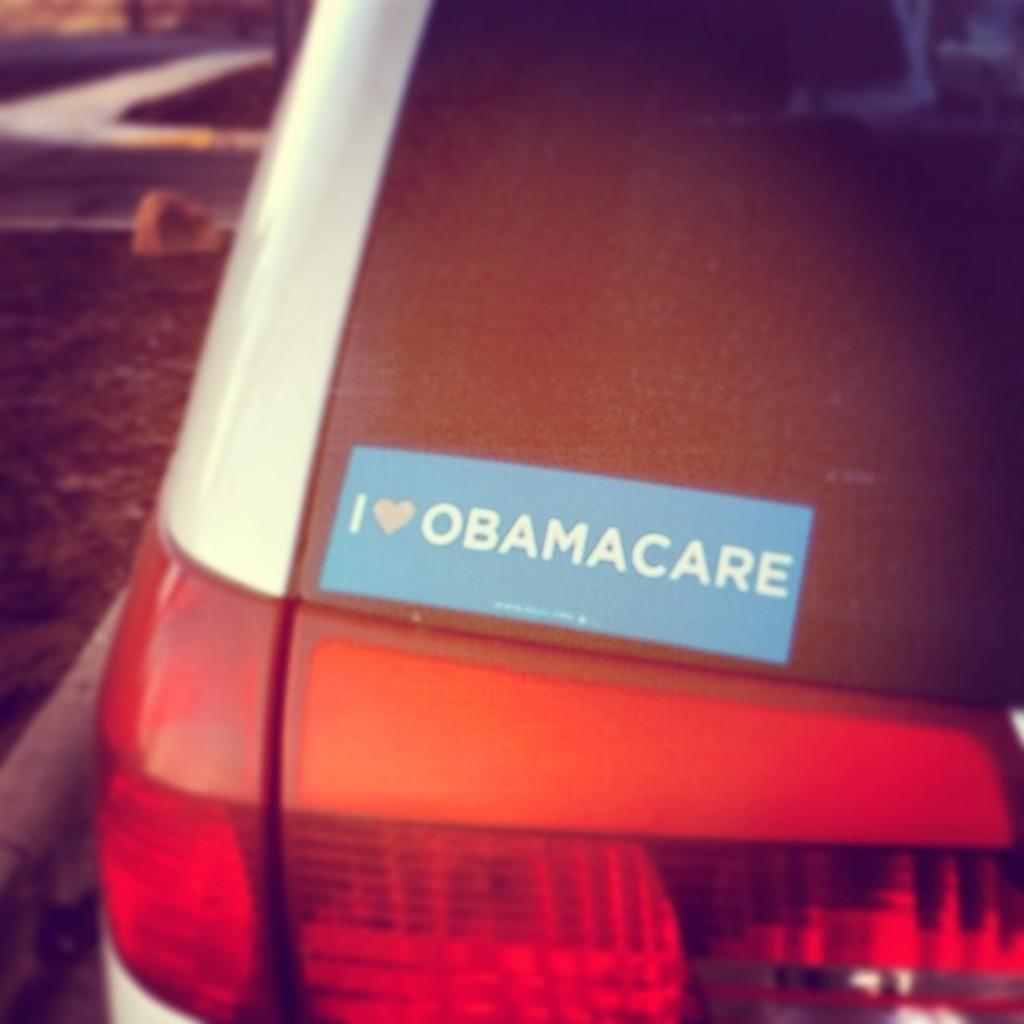What is the main subject in the image? There is a vehicle in the image. Can you describe the background of the image? The background of the image is blurry. What might the blurry background represent? The blurry background is likely to be a road. How many pies are being sold by the vehicle in the image? There is no indication of pies being sold or present in the image. Is there any rain visible in the image? There is no mention of rain or any weather conditions in the image. 